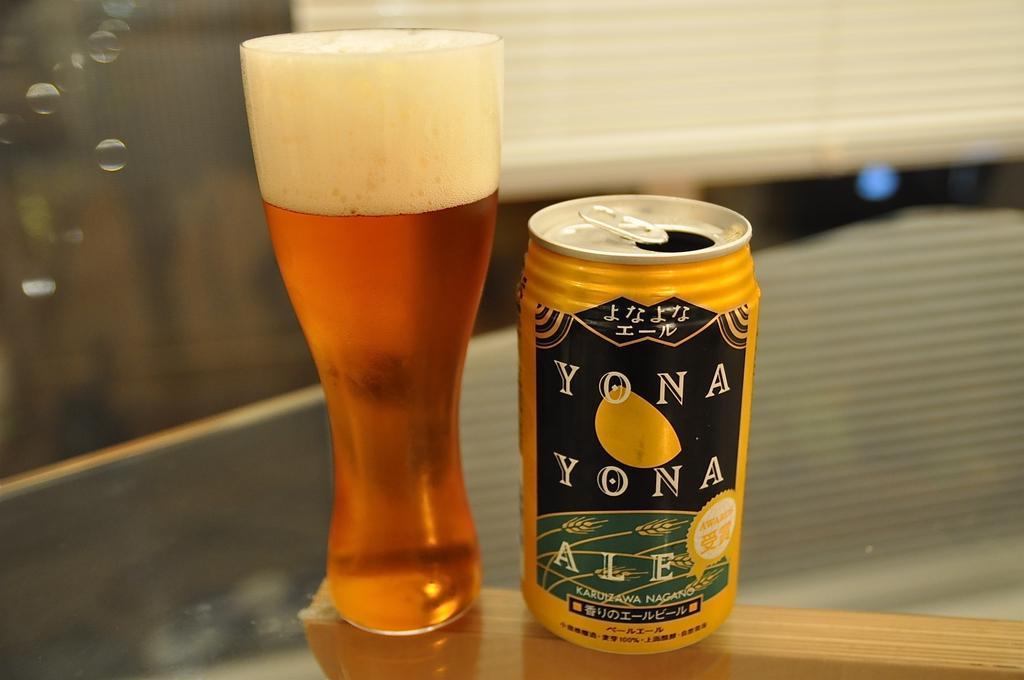Please provide a concise description of this image. In this image in the center there is one coke container beside the coke container there is one glass and in that glass there is some drink, in the background there is wall. At the bottom there is a table. 